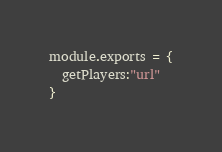Convert code to text. <code><loc_0><loc_0><loc_500><loc_500><_JavaScript_>module.exports = {
  getPlayers:"url"
}
</code> 